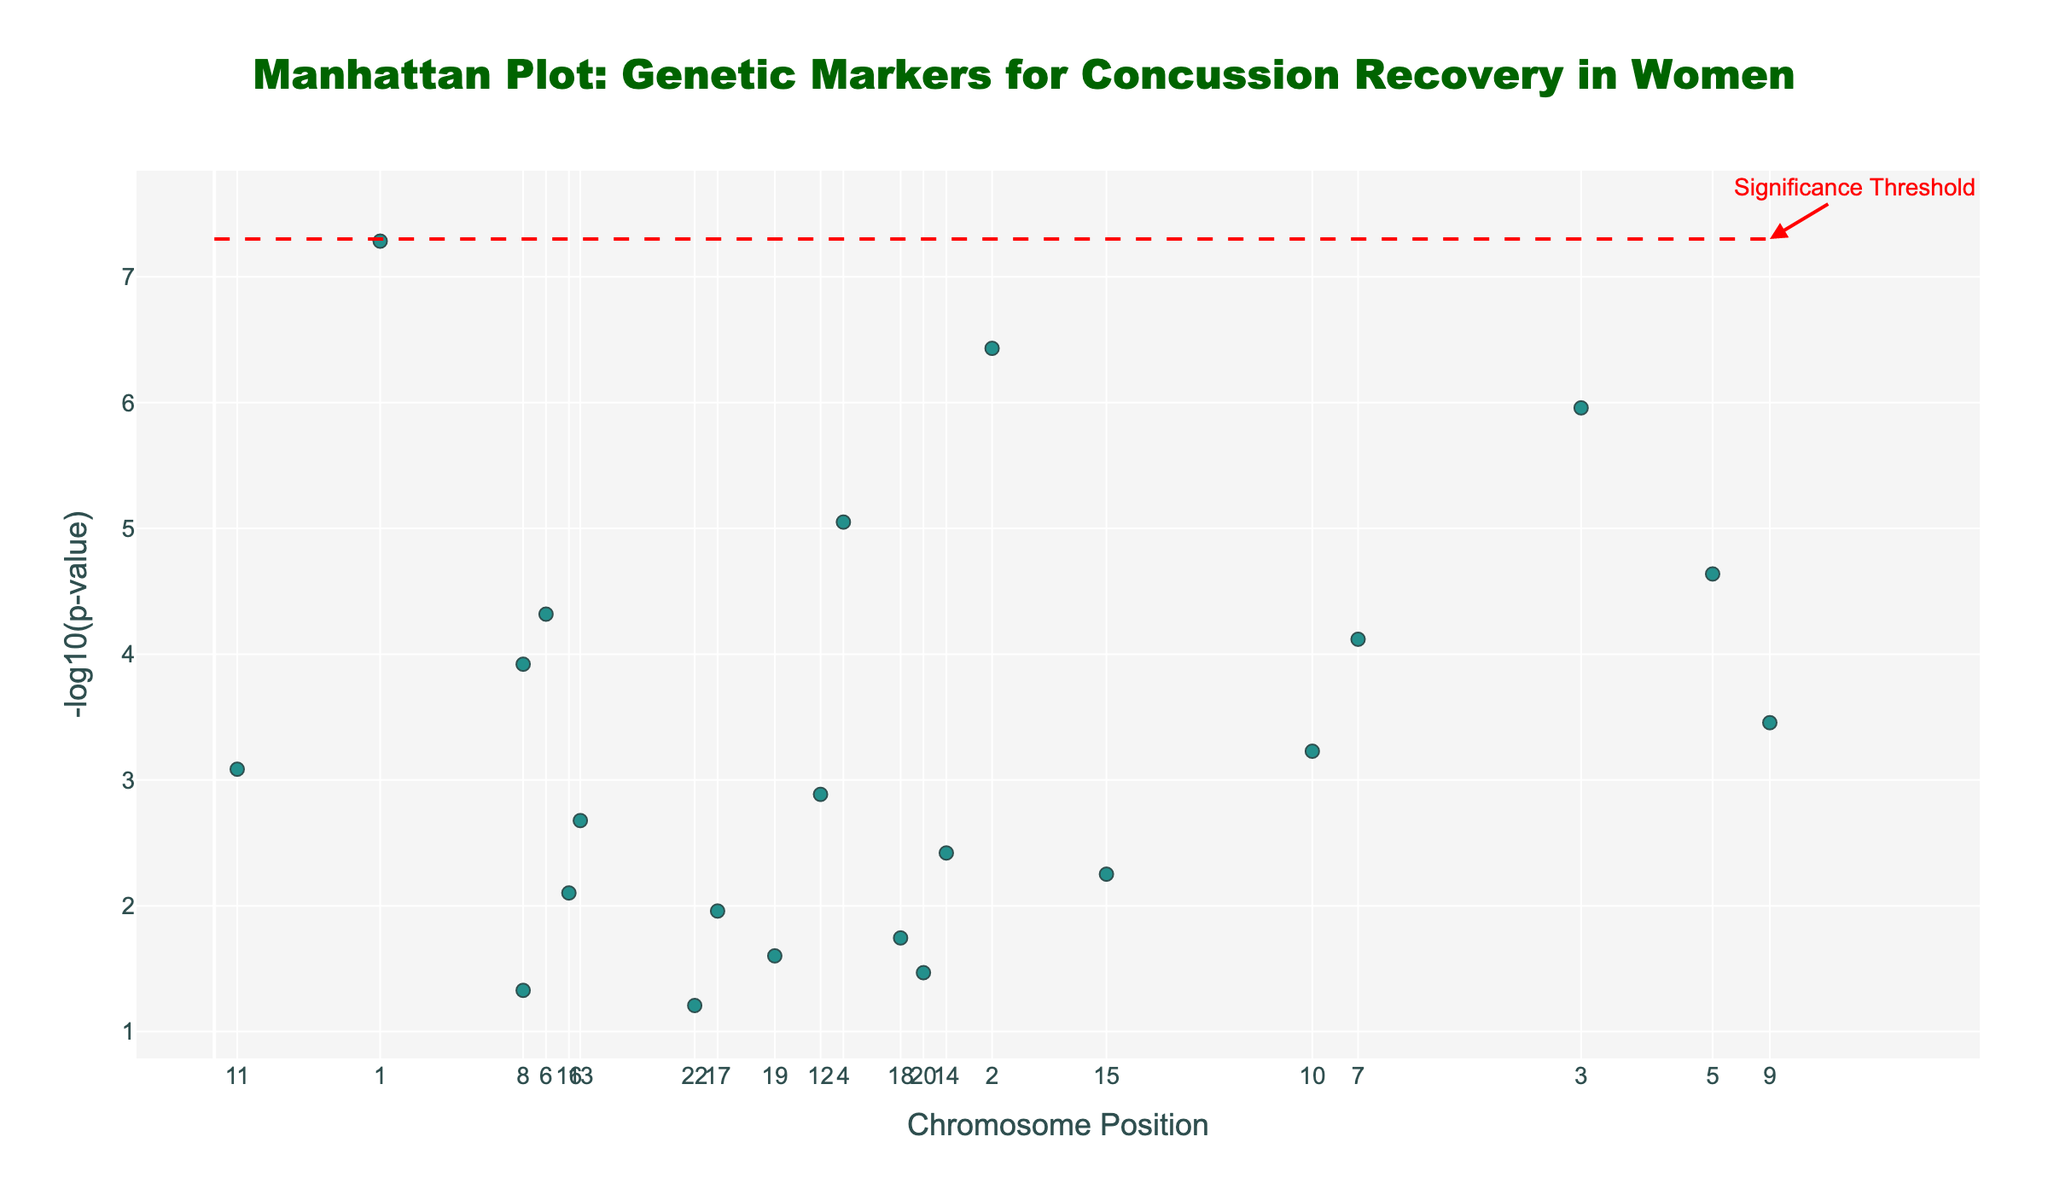What is the title of the plot? The title of the plot is displayed at the top center of the figure. It reads "Manhattan Plot: Genetic Markers for Concussion Recovery in Women".
Answer: Manhattan Plot: Genetic Markers for Concussion Recovery in Women What is represented on the x-axis? The x-axis represents the chromosome positions, with tick labels showing chromosome numbers from 1 to 22.
Answer: Chromosome Position What does the y-axis represent? The y-axis represents the negative logarithm of the p-value (-log10(p-value)). This helps visualize the significance of the genetic markers.
Answer: -log10(p-value) Which chromosome has the gene with the lowest p-value? To determine this, we look for the data point with the highest value on the y-axis (since lower p-values correspond to higher -log10(p-values)). The highest point is on Chromosome 1.
Answer: Chromosome 1 What color is used to mark significant genetic markers? Significant genetic markers are highlighted by their prominence on the y-axis (above the horizontal red line), and their color is part of the Viridis color scale used for the dots.
Answer: Part of Viridis color scale How many genetic markers have a p-value below the significance threshold? The significance threshold is represented by a horizontal red dashed line. Counting the points above this line indicates the number of genetic markers below the significance threshold.
Answer: 1 Which gene has the second highest -log10(p-value)? Looking at the second highest point on the y-axis and identifying the gene associated with that point will reveal the answer. This point is for the gene BDNF on Chromosome 2.
Answer: BDNF What is the approximate -log10(p-value) cutoff for the significance threshold? The horizontal red dashed line represents this threshold. Reading the y-axis value where this line is drawn gives an approximate -log10(p-value).
Answer: ~7.3 How do the p-values of genes on Chromosome 1 compare? To compare the p-values, we look at the height of the points on the y-axis. Chromosome 1 includes genes, among which APOE has the highest -log10(p-value) indicating the lowest p-value.
Answer: APOE has the lowest p-value Which gene is located at position 49000000 on Chromosome 19? By inspecting the genes listed under Chromosome 19 in the plot, the gene located at position 49000000 is APOE_RS429358.
Answer: APOE_RS429358 